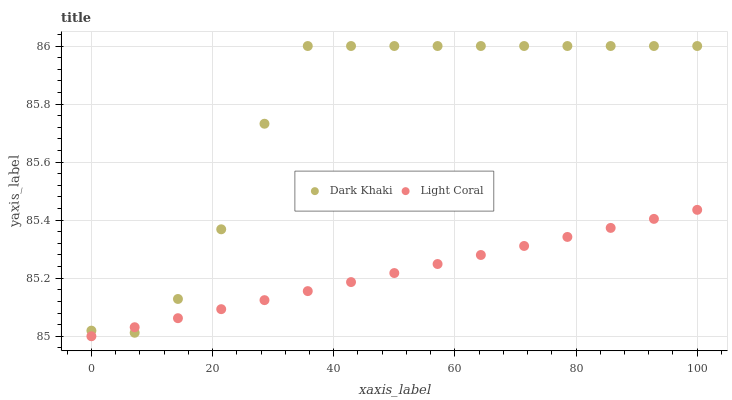Does Light Coral have the minimum area under the curve?
Answer yes or no. Yes. Does Dark Khaki have the maximum area under the curve?
Answer yes or no. Yes. Does Light Coral have the maximum area under the curve?
Answer yes or no. No. Is Light Coral the smoothest?
Answer yes or no. Yes. Is Dark Khaki the roughest?
Answer yes or no. Yes. Is Light Coral the roughest?
Answer yes or no. No. Does Light Coral have the lowest value?
Answer yes or no. Yes. Does Dark Khaki have the highest value?
Answer yes or no. Yes. Does Light Coral have the highest value?
Answer yes or no. No. Does Light Coral intersect Dark Khaki?
Answer yes or no. Yes. Is Light Coral less than Dark Khaki?
Answer yes or no. No. Is Light Coral greater than Dark Khaki?
Answer yes or no. No. 